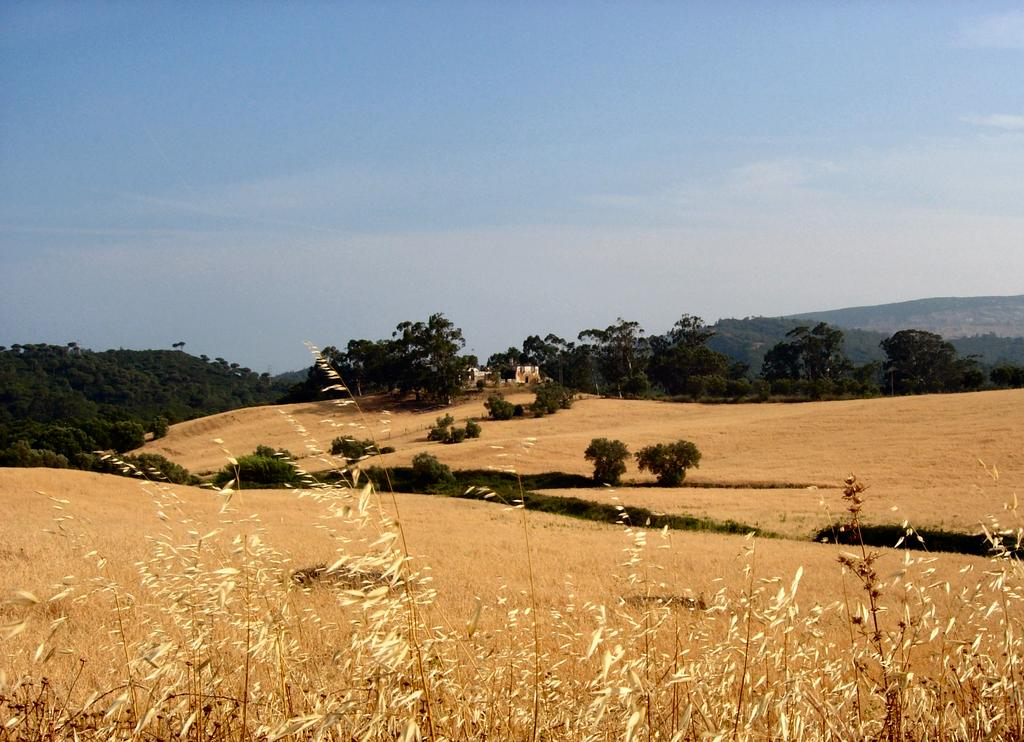What type of vegetation can be seen in the image? There are plants, trees, and grass in the image. Can you describe the natural environment depicted in the image? The image features a variety of vegetation, including plants, trees, and grass. What color is the ear of the person in the image? There is no person present in the image, only plants, trees, and grass. Where is the stove located in the image? There is no stove present in the image; it features a natural environment with vegetation. 